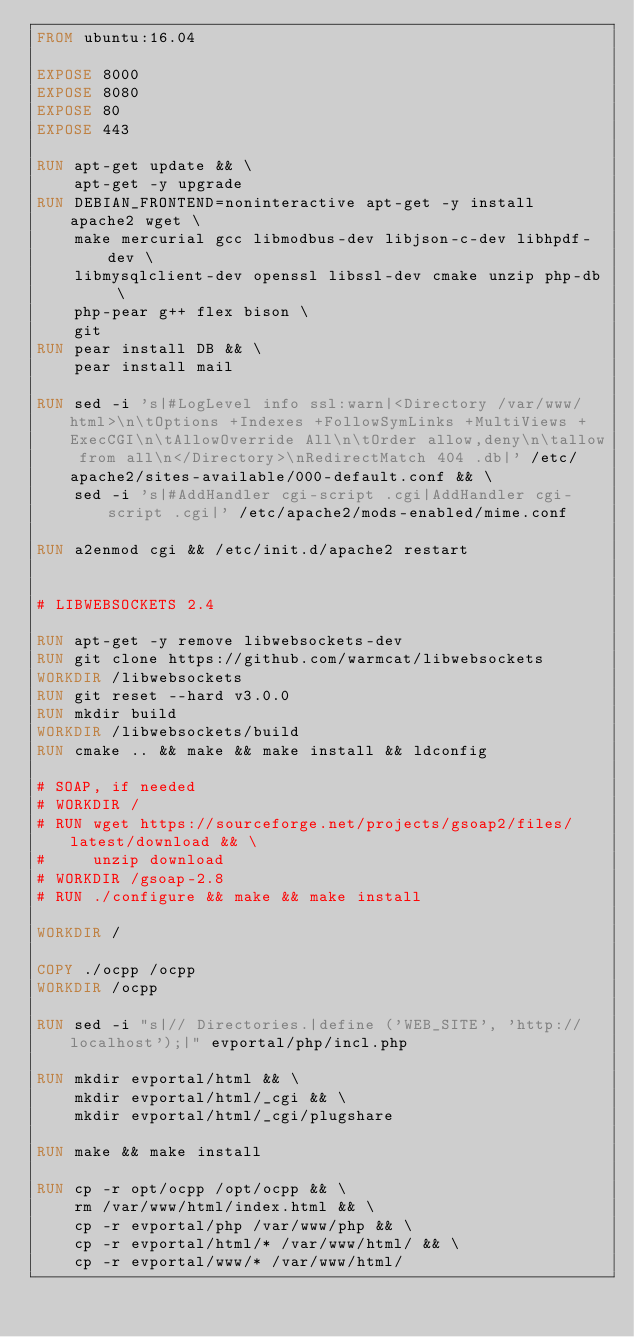Convert code to text. <code><loc_0><loc_0><loc_500><loc_500><_Dockerfile_>FROM ubuntu:16.04

EXPOSE 8000
EXPOSE 8080
EXPOSE 80
EXPOSE 443

RUN apt-get update && \
    apt-get -y upgrade
RUN DEBIAN_FRONTEND=noninteractive apt-get -y install apache2 wget \
    make mercurial gcc libmodbus-dev libjson-c-dev libhpdf-dev \
    libmysqlclient-dev openssl libssl-dev cmake unzip php-db \
    php-pear g++ flex bison \
    git
RUN pear install DB && \
    pear install mail

RUN sed -i 's|#LogLevel info ssl:warn|<Directory /var/www/html>\n\tOptions +Indexes +FollowSymLinks +MultiViews +ExecCGI\n\tAllowOverride All\n\tOrder allow,deny\n\tallow from all\n</Directory>\nRedirectMatch 404 .db|' /etc/apache2/sites-available/000-default.conf && \
    sed -i 's|#AddHandler cgi-script .cgi|AddHandler cgi-script .cgi|' /etc/apache2/mods-enabled/mime.conf

RUN a2enmod cgi && /etc/init.d/apache2 restart


# LIBWEBSOCKETS 2.4

RUN apt-get -y remove libwebsockets-dev
RUN git clone https://github.com/warmcat/libwebsockets
WORKDIR /libwebsockets
RUN git reset --hard v3.0.0
RUN mkdir build
WORKDIR /libwebsockets/build
RUN cmake .. && make && make install && ldconfig

# SOAP, if needed
# WORKDIR /
# RUN wget https://sourceforge.net/projects/gsoap2/files/latest/download && \
#     unzip download
# WORKDIR /gsoap-2.8
# RUN ./configure && make && make install

WORKDIR /

COPY ./ocpp /ocpp
WORKDIR /ocpp

RUN sed -i "s|// Directories.|define ('WEB_SITE', 'http://localhost');|" evportal/php/incl.php

RUN mkdir evportal/html && \
    mkdir evportal/html/_cgi && \
    mkdir evportal/html/_cgi/plugshare

RUN make && make install

RUN cp -r opt/ocpp /opt/ocpp && \
    rm /var/www/html/index.html && \
    cp -r evportal/php /var/www/php && \
    cp -r evportal/html/* /var/www/html/ && \
    cp -r evportal/www/* /var/www/html/
</code> 